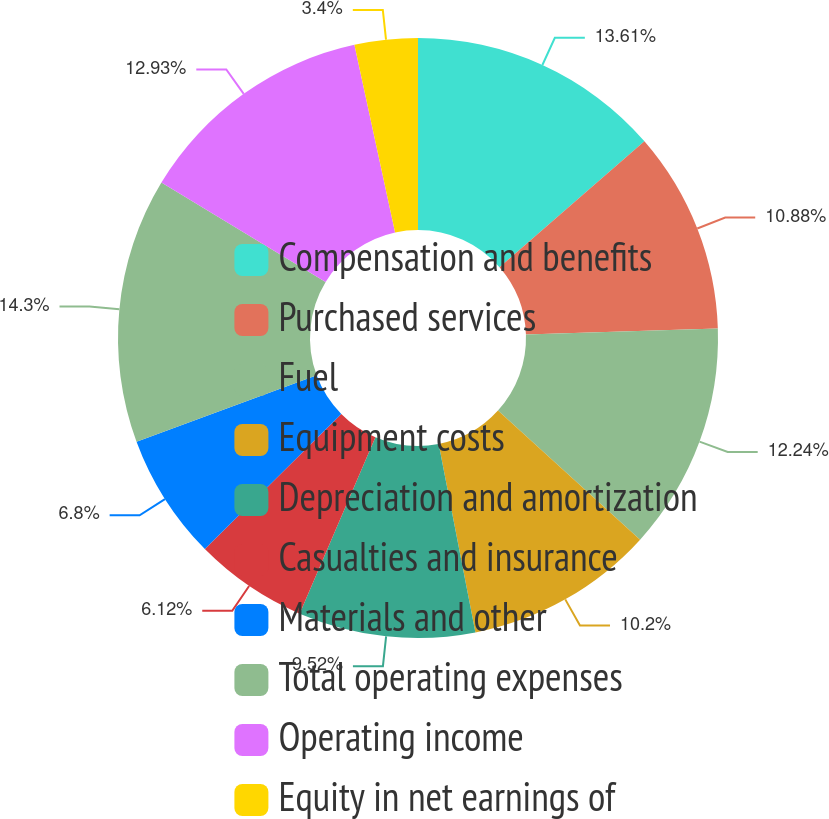Convert chart to OTSL. <chart><loc_0><loc_0><loc_500><loc_500><pie_chart><fcel>Compensation and benefits<fcel>Purchased services<fcel>Fuel<fcel>Equipment costs<fcel>Depreciation and amortization<fcel>Casualties and insurance<fcel>Materials and other<fcel>Total operating expenses<fcel>Operating income<fcel>Equity in net earnings of<nl><fcel>13.61%<fcel>10.88%<fcel>12.24%<fcel>10.2%<fcel>9.52%<fcel>6.12%<fcel>6.8%<fcel>14.29%<fcel>12.93%<fcel>3.4%<nl></chart> 